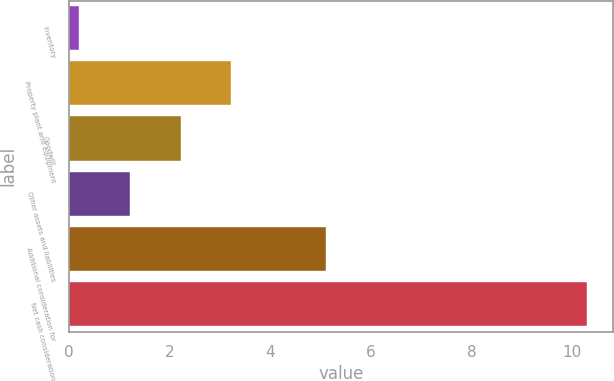<chart> <loc_0><loc_0><loc_500><loc_500><bar_chart><fcel>Inventory<fcel>Property plant and equipment<fcel>Goodwill<fcel>Other assets and liabilities<fcel>Additional consideration for<fcel>Net cash consideration<nl><fcel>0.2<fcel>3.23<fcel>2.22<fcel>1.21<fcel>5.1<fcel>10.3<nl></chart> 